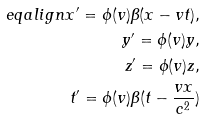<formula> <loc_0><loc_0><loc_500><loc_500>\ e q a l i g n x ^ { \prime } = \phi ( v ) \beta ( x - v t ) , \\ y ^ { \prime } = \phi ( v ) y , \\ z ^ { \prime } = \phi ( v ) z , \\ t ^ { \prime } = \phi ( v ) \beta ( t - \frac { v x } { c ^ { 2 } } )</formula> 